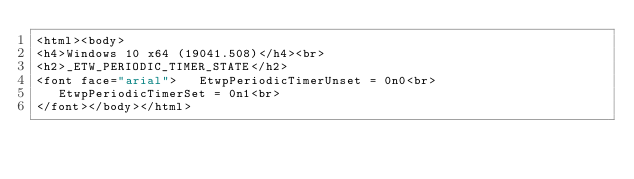<code> <loc_0><loc_0><loc_500><loc_500><_HTML_><html><body>
<h4>Windows 10 x64 (19041.508)</h4><br>
<h2>_ETW_PERIODIC_TIMER_STATE</h2>
<font face="arial">   EtwpPeriodicTimerUnset = 0n0<br>
   EtwpPeriodicTimerSet = 0n1<br>
</font></body></html></code> 